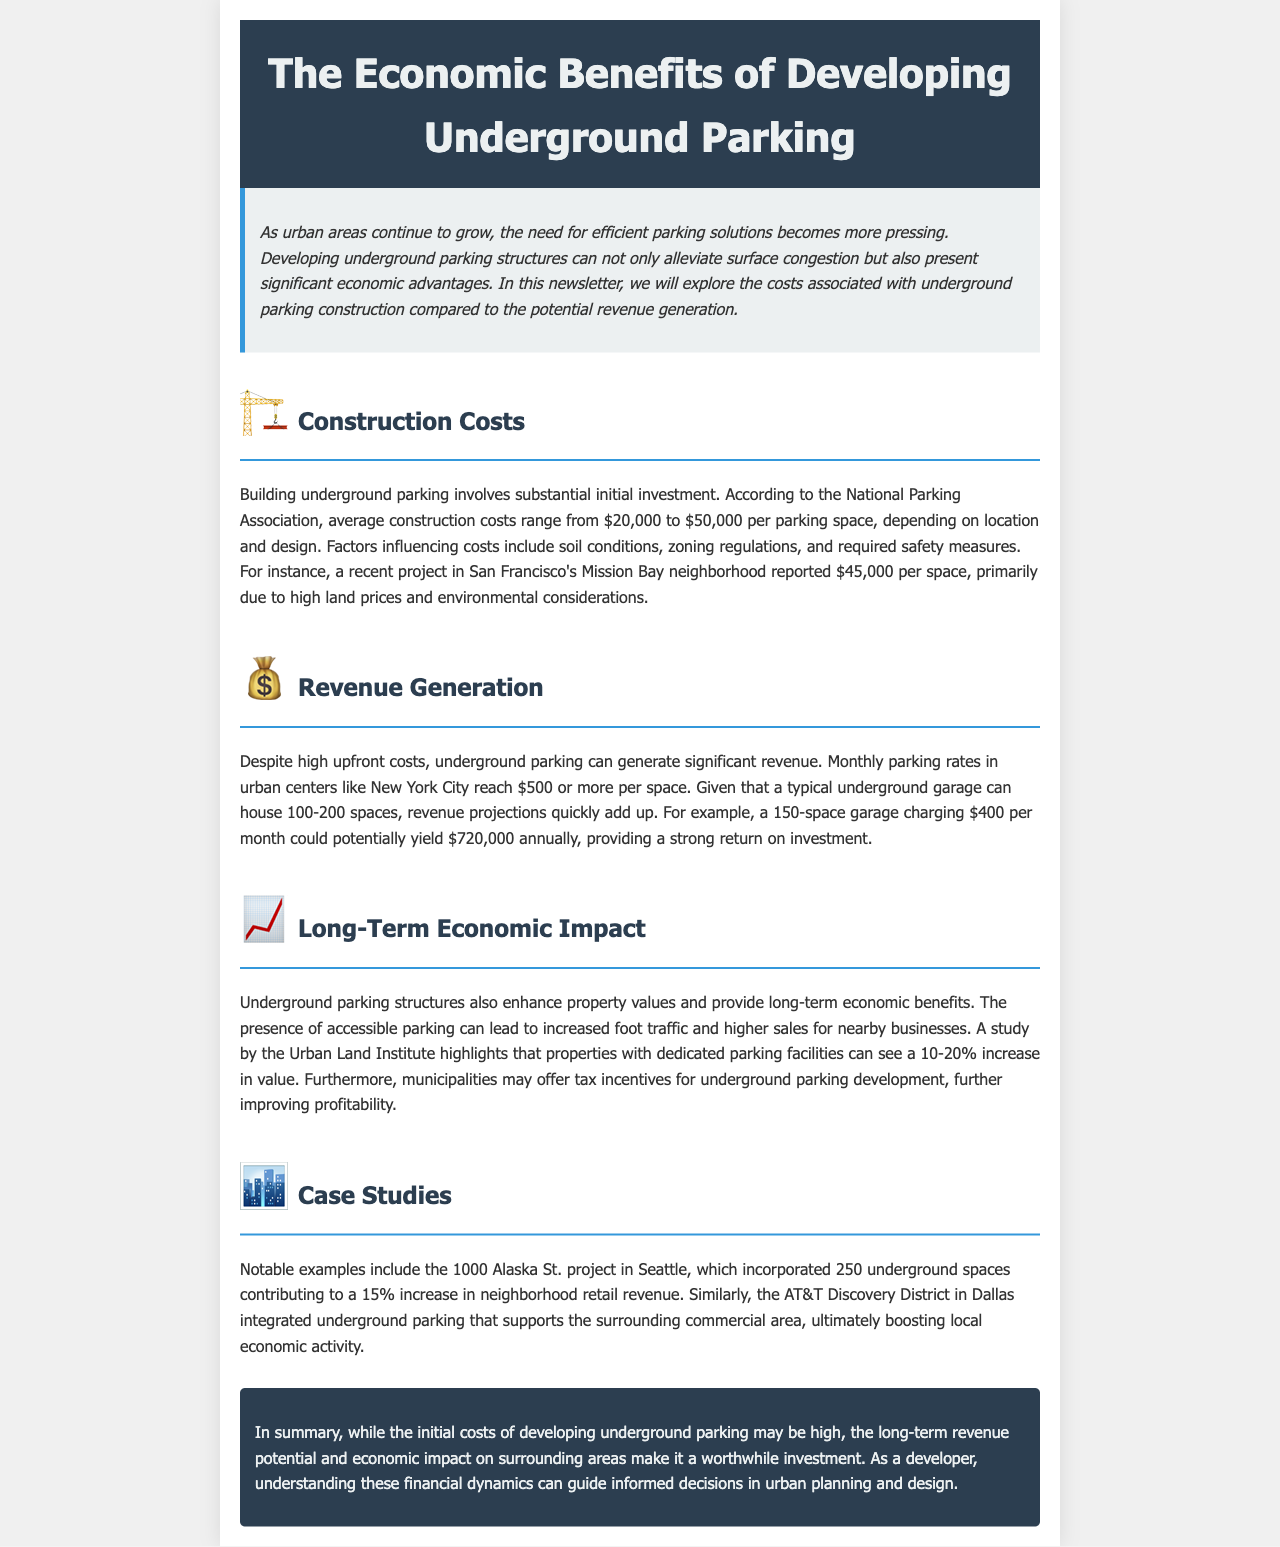what is the average construction cost per parking space? The average construction costs range from $20,000 to $50,000 per parking space, depending on location and design.
Answer: $20,000 to $50,000 what is the potential annual revenue of a 150-space garage charging $400 monthly? The potential annual revenue from a 150-space garage charging $400 per month can be calculated as 150 spaces * $400 * 12 months = $720,000.
Answer: $720,000 which city reported a construction cost of $45,000 per space? The document mentions a project in San Francisco's Mission Bay neighborhood that reported $45,000 per space.
Answer: San Francisco what percentage increase in property values is highlighted by the Urban Land Institute? The Urban Land Institute highlights a 10-20% increase in property values with the presence of dedicated parking facilities.
Answer: 10-20% how many underground spaces were included in the 1000 Alaska St. project? The 1000 Alaska St. project in Seattle incorporated 250 underground spaces.
Answer: 250 what factor influences construction costs mentioned in the document? The document lists soil conditions, zoning regulations, and required safety measures as factors influencing construction costs.
Answer: Soil conditions how does underground parking benefit nearby businesses? The presence of accessible parking can lead to increased foot traffic and higher sales for nearby businesses.
Answer: Increased foot traffic what is the primary economic advantage of developing underground parking according to the newsletter? The newsletter suggests that the long-term revenue potential and economic impact on surrounding areas are the primary economic advantages.
Answer: Revenue potential and economic impact 